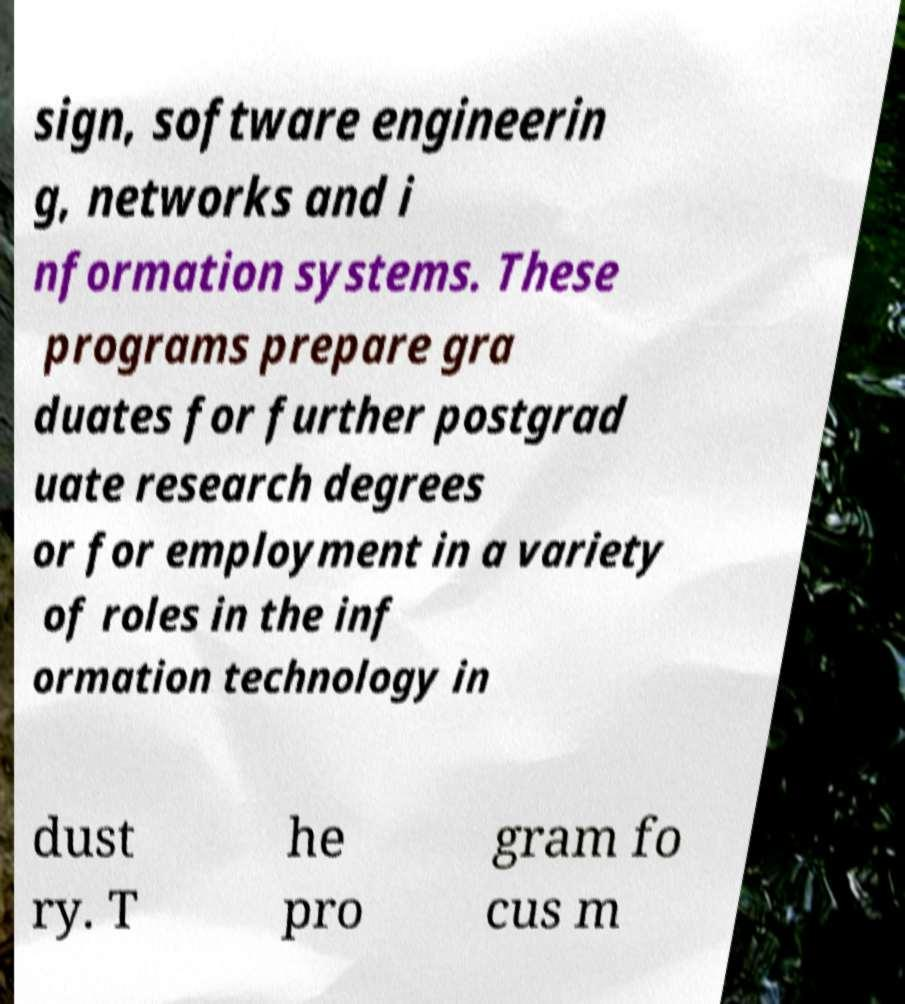There's text embedded in this image that I need extracted. Can you transcribe it verbatim? sign, software engineerin g, networks and i nformation systems. These programs prepare gra duates for further postgrad uate research degrees or for employment in a variety of roles in the inf ormation technology in dust ry. T he pro gram fo cus m 